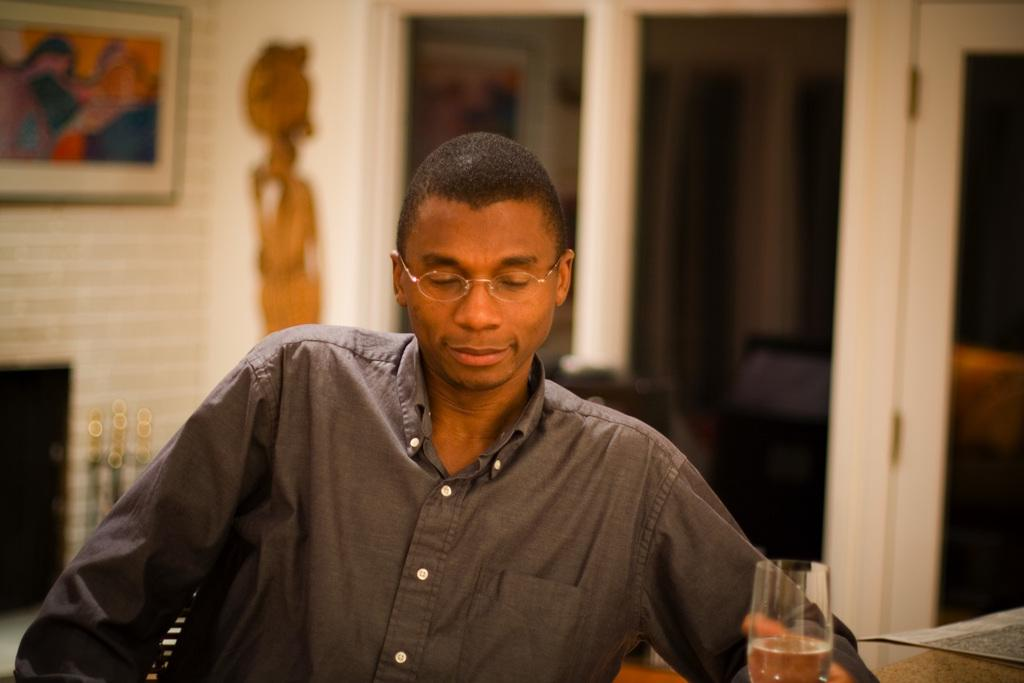What is the main subject of the image? There is a man in the image. What object is visible near the man? There is a glass in the image. Can you describe the background of the image? The background of the image is blurred. What type of pencil is the man using to draw in the image? There is no pencil present in the image, and the man is not shown drawing. 